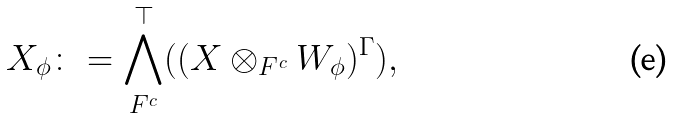Convert formula to latex. <formula><loc_0><loc_0><loc_500><loc_500>X _ { \phi } \colon = \bigwedge ^ { \top } _ { F ^ { c } } ( ( X \otimes _ { F ^ { c } } W _ { \phi } ) ^ { \Gamma } ) ,</formula> 